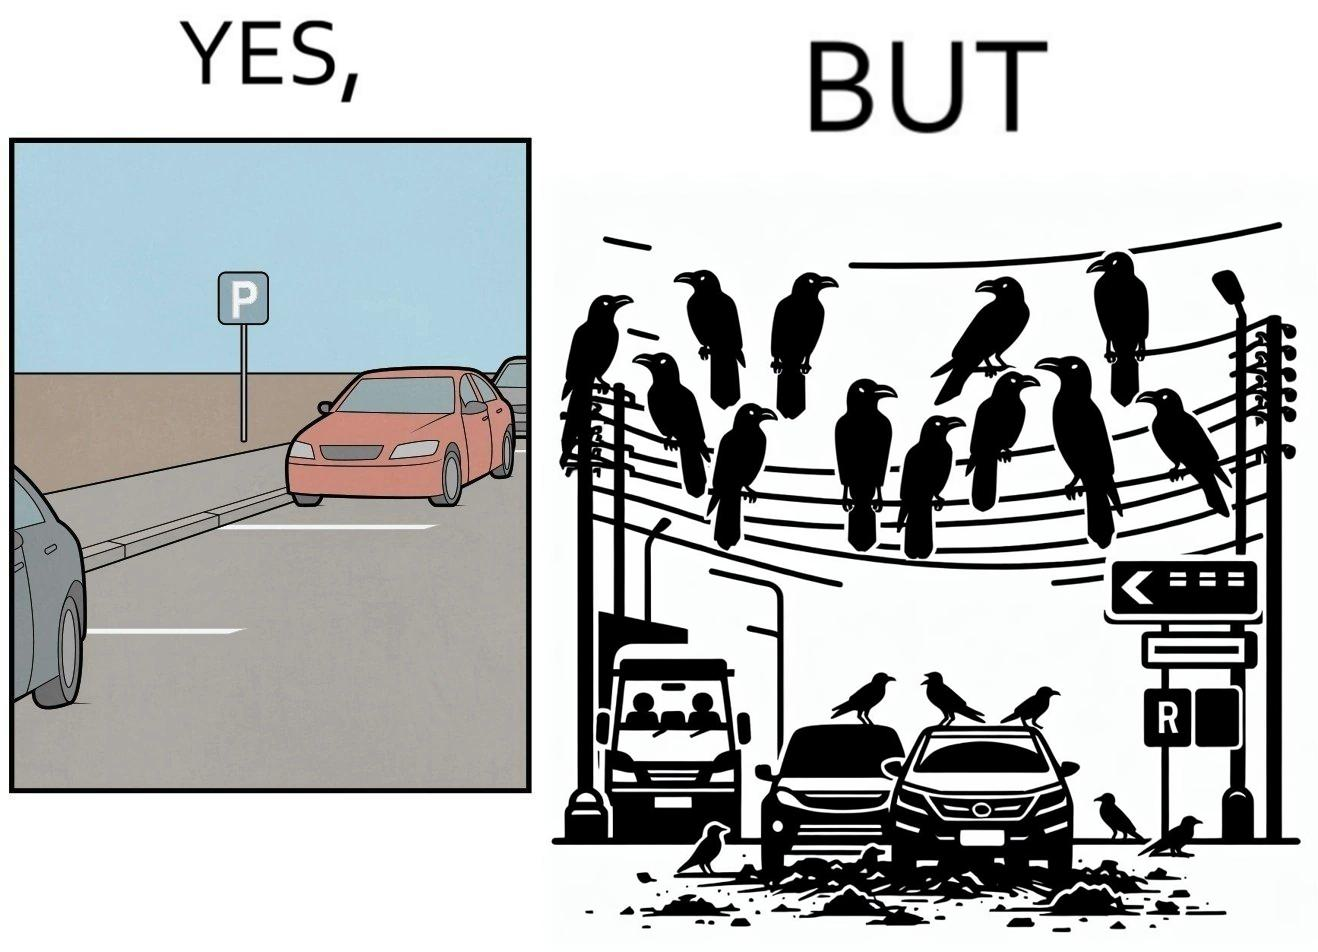Compare the left and right sides of this image. In the left part of the image: There is a parking place where few cars are standing leaving a place in middle. In the right part of the image: Some crows are sitting on a wire which is above the parking area and the crows are making that place dirty. 